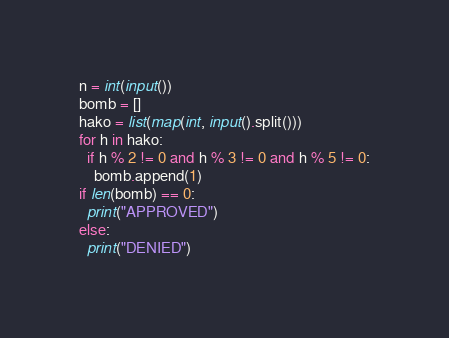<code> <loc_0><loc_0><loc_500><loc_500><_Python_>n = int(input())
bomb = []
hako = list(map(int, input().split()))
for h in hako:
  if h % 2 != 0 and h % 3 != 0 and h % 5 != 0:
    bomb.append(1)
if len(bomb) == 0:
  print("APPROVED")
else:
  print("DENIED")</code> 